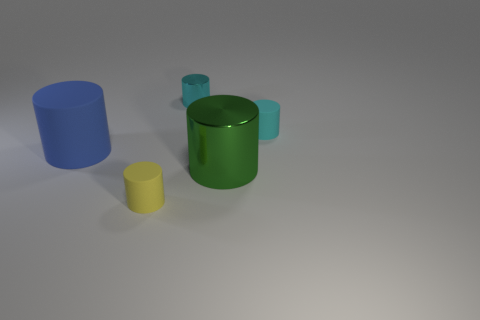Are there the same number of cyan metallic cylinders in front of the yellow matte object and red shiny blocks?
Your answer should be compact. Yes. What number of other things are the same size as the blue matte cylinder?
Your response must be concise. 1. Do the big object to the right of the small yellow cylinder and the small thing in front of the blue matte cylinder have the same material?
Provide a short and direct response. No. What is the size of the matte cylinder to the left of the tiny rubber cylinder in front of the big green cylinder?
Your answer should be very brief. Large. Is there a matte object that has the same color as the tiny shiny cylinder?
Offer a terse response. Yes. Does the metallic cylinder behind the big green shiny object have the same color as the rubber cylinder behind the big rubber cylinder?
Offer a very short reply. Yes. The big blue matte object is what shape?
Your answer should be very brief. Cylinder. What number of green things are to the left of the blue rubber object?
Ensure brevity in your answer.  0. How many green things have the same material as the green cylinder?
Offer a terse response. 0. Do the cyan object behind the small cyan matte cylinder and the large blue cylinder have the same material?
Keep it short and to the point. No. 